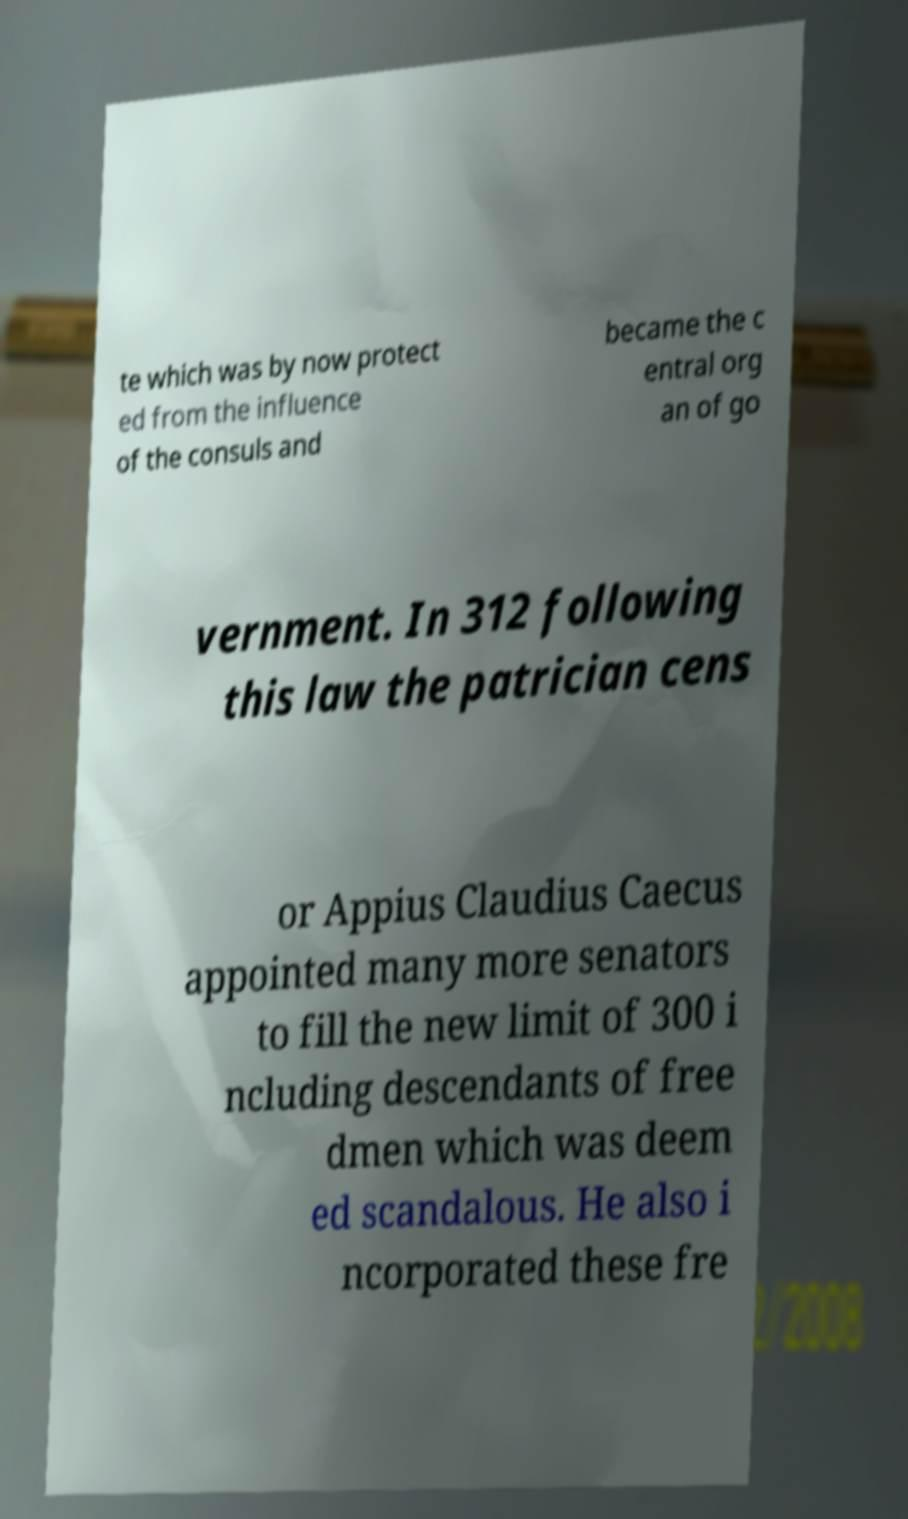Please read and relay the text visible in this image. What does it say? te which was by now protect ed from the influence of the consuls and became the c entral org an of go vernment. In 312 following this law the patrician cens or Appius Claudius Caecus appointed many more senators to fill the new limit of 300 i ncluding descendants of free dmen which was deem ed scandalous. He also i ncorporated these fre 